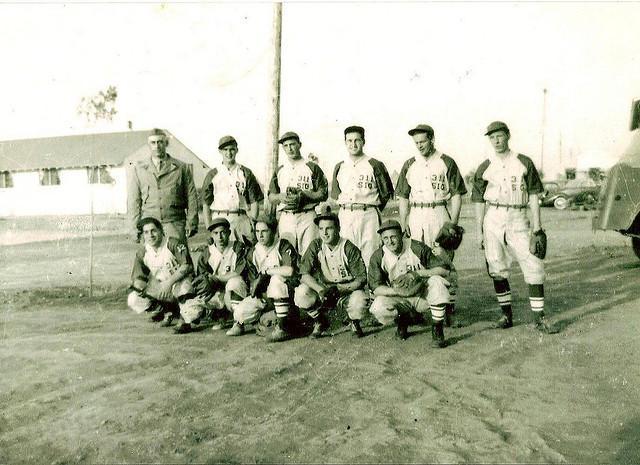How many guys are here?
Give a very brief answer. 11. How many people are there?
Give a very brief answer. 11. 